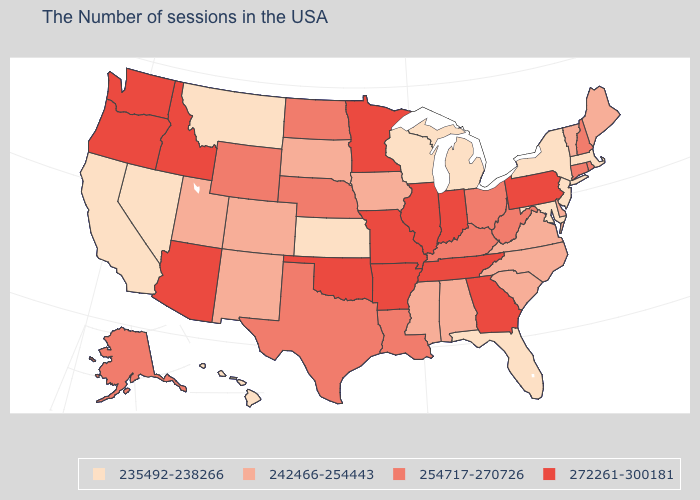Name the states that have a value in the range 254717-270726?
Quick response, please. Rhode Island, New Hampshire, Connecticut, West Virginia, Ohio, Kentucky, Louisiana, Nebraska, Texas, North Dakota, Wyoming, Alaska. Does the first symbol in the legend represent the smallest category?
Answer briefly. Yes. How many symbols are there in the legend?
Give a very brief answer. 4. Among the states that border North Dakota , does Montana have the lowest value?
Keep it brief. Yes. What is the value of Minnesota?
Be succinct. 272261-300181. What is the value of Iowa?
Answer briefly. 242466-254443. Among the states that border Illinois , does Missouri have the highest value?
Give a very brief answer. Yes. Name the states that have a value in the range 242466-254443?
Short answer required. Maine, Vermont, Delaware, Virginia, North Carolina, South Carolina, Alabama, Mississippi, Iowa, South Dakota, Colorado, New Mexico, Utah. Name the states that have a value in the range 235492-238266?
Short answer required. Massachusetts, New York, New Jersey, Maryland, Florida, Michigan, Wisconsin, Kansas, Montana, Nevada, California, Hawaii. Does Hawaii have the lowest value in the USA?
Be succinct. Yes. Name the states that have a value in the range 254717-270726?
Short answer required. Rhode Island, New Hampshire, Connecticut, West Virginia, Ohio, Kentucky, Louisiana, Nebraska, Texas, North Dakota, Wyoming, Alaska. What is the value of New York?
Quick response, please. 235492-238266. Does Virginia have the same value as Ohio?
Short answer required. No. Name the states that have a value in the range 254717-270726?
Keep it brief. Rhode Island, New Hampshire, Connecticut, West Virginia, Ohio, Kentucky, Louisiana, Nebraska, Texas, North Dakota, Wyoming, Alaska. Name the states that have a value in the range 272261-300181?
Be succinct. Pennsylvania, Georgia, Indiana, Tennessee, Illinois, Missouri, Arkansas, Minnesota, Oklahoma, Arizona, Idaho, Washington, Oregon. 